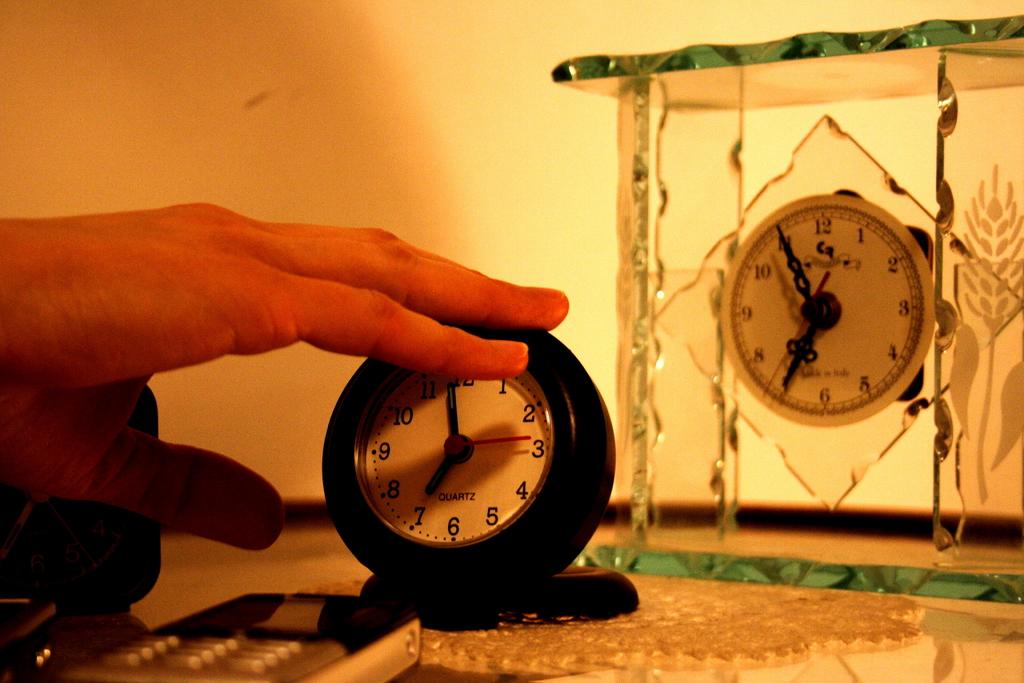What is the time on the clock at the back?
Provide a short and direct response. 6:55. 